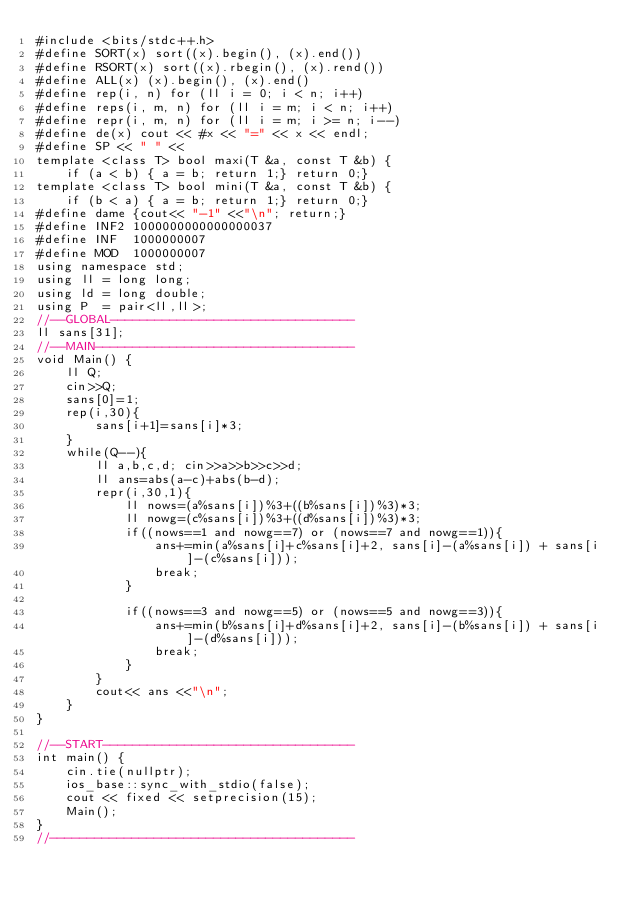<code> <loc_0><loc_0><loc_500><loc_500><_C++_>#include <bits/stdc++.h>
#define SORT(x) sort((x).begin(), (x).end())
#define RSORT(x) sort((x).rbegin(), (x).rend())
#define ALL(x) (x).begin(), (x).end()
#define rep(i, n) for (ll i = 0; i < n; i++)
#define reps(i, m, n) for (ll i = m; i < n; i++)
#define repr(i, m, n) for (ll i = m; i >= n; i--)
#define de(x) cout << #x << "=" << x << endl;
#define SP << " " <<
template <class T> bool maxi(T &a, const T &b) {
    if (a < b) { a = b; return 1;} return 0;}
template <class T> bool mini(T &a, const T &b) {
    if (b < a) { a = b; return 1;} return 0;}
#define dame {cout<< "-1" <<"\n"; return;}
#define INF2 1000000000000000037
#define INF  1000000007
#define MOD  1000000007
using namespace std;
using ll = long long;
using ld = long double;
using P  = pair<ll,ll>;
//--GLOBAL---------------------------------
ll sans[31];
//--MAIN-----------------------------------
void Main() {
    ll Q;
    cin>>Q;
    sans[0]=1;
    rep(i,30){
        sans[i+1]=sans[i]*3;
    }
    while(Q--){
        ll a,b,c,d; cin>>a>>b>>c>>d;
        ll ans=abs(a-c)+abs(b-d);
        repr(i,30,1){
            ll nows=(a%sans[i])%3+((b%sans[i])%3)*3;
            ll nowg=(c%sans[i])%3+((d%sans[i])%3)*3;
            if((nows==1 and nowg==7) or (nows==7 and nowg==1)){
                ans+=min(a%sans[i]+c%sans[i]+2, sans[i]-(a%sans[i]) + sans[i]-(c%sans[i]));
                break;
            }

            if((nows==3 and nowg==5) or (nows==5 and nowg==3)){
                ans+=min(b%sans[i]+d%sans[i]+2, sans[i]-(b%sans[i]) + sans[i]-(d%sans[i]));
                break;
            }
        }
        cout<< ans <<"\n";
    }
}

//--START----------------------------------
int main() {
    cin.tie(nullptr);
    ios_base::sync_with_stdio(false);
    cout << fixed << setprecision(15);
    Main();
}
//-----------------------------------------
</code> 